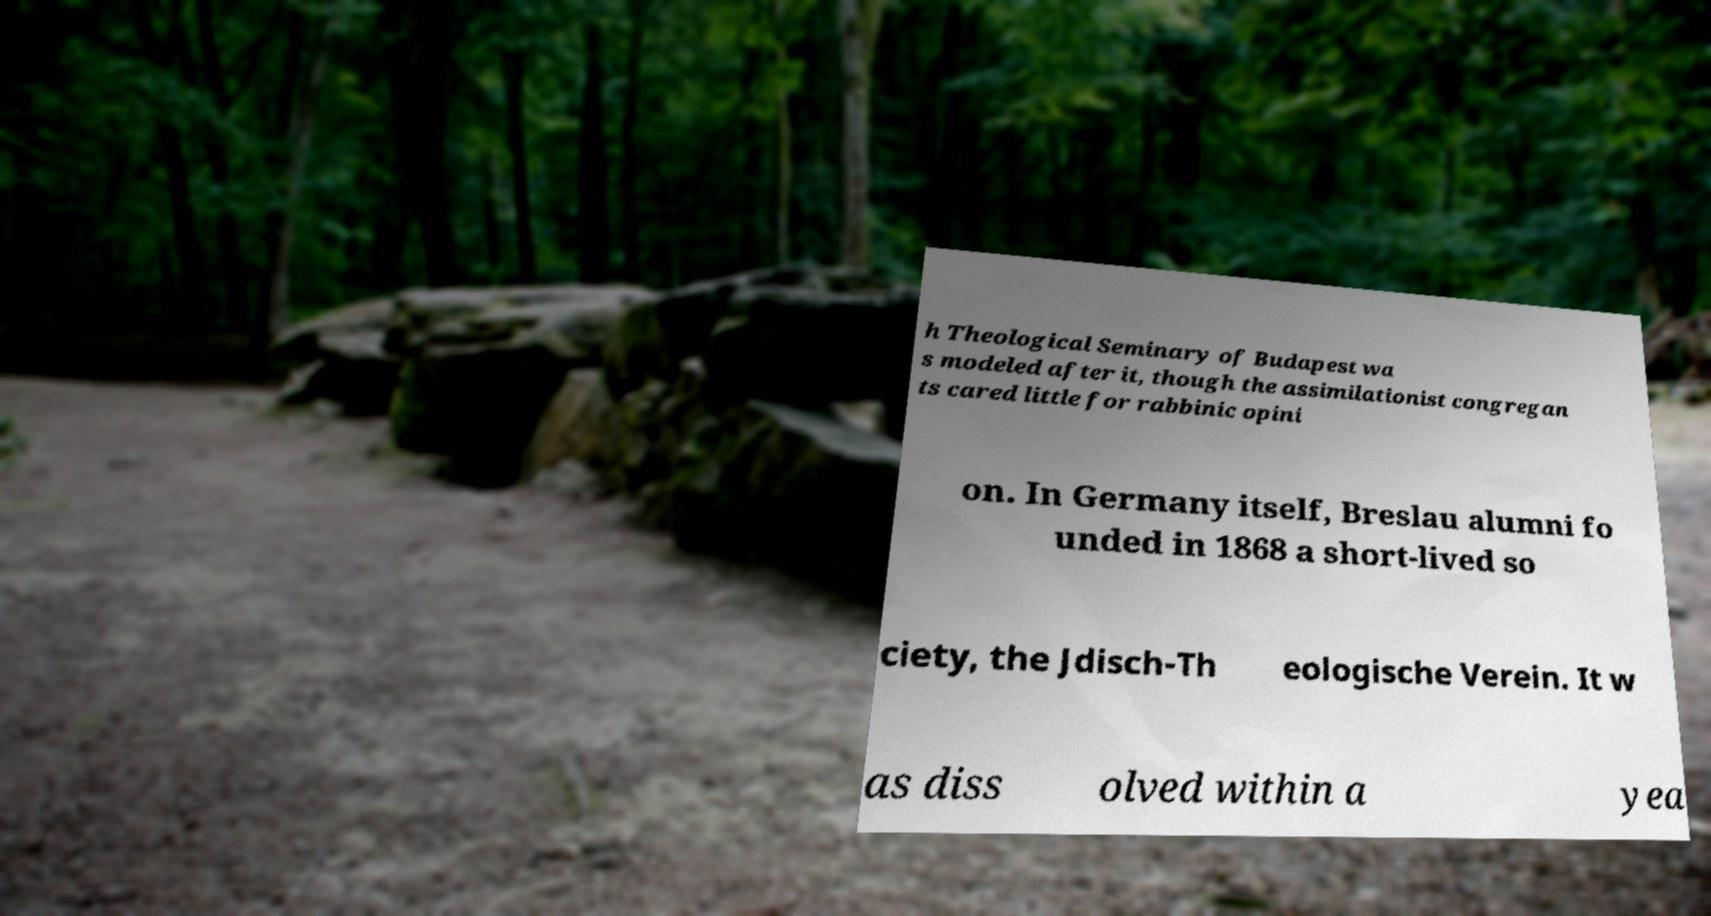For documentation purposes, I need the text within this image transcribed. Could you provide that? h Theological Seminary of Budapest wa s modeled after it, though the assimilationist congregan ts cared little for rabbinic opini on. In Germany itself, Breslau alumni fo unded in 1868 a short-lived so ciety, the Jdisch-Th eologische Verein. It w as diss olved within a yea 